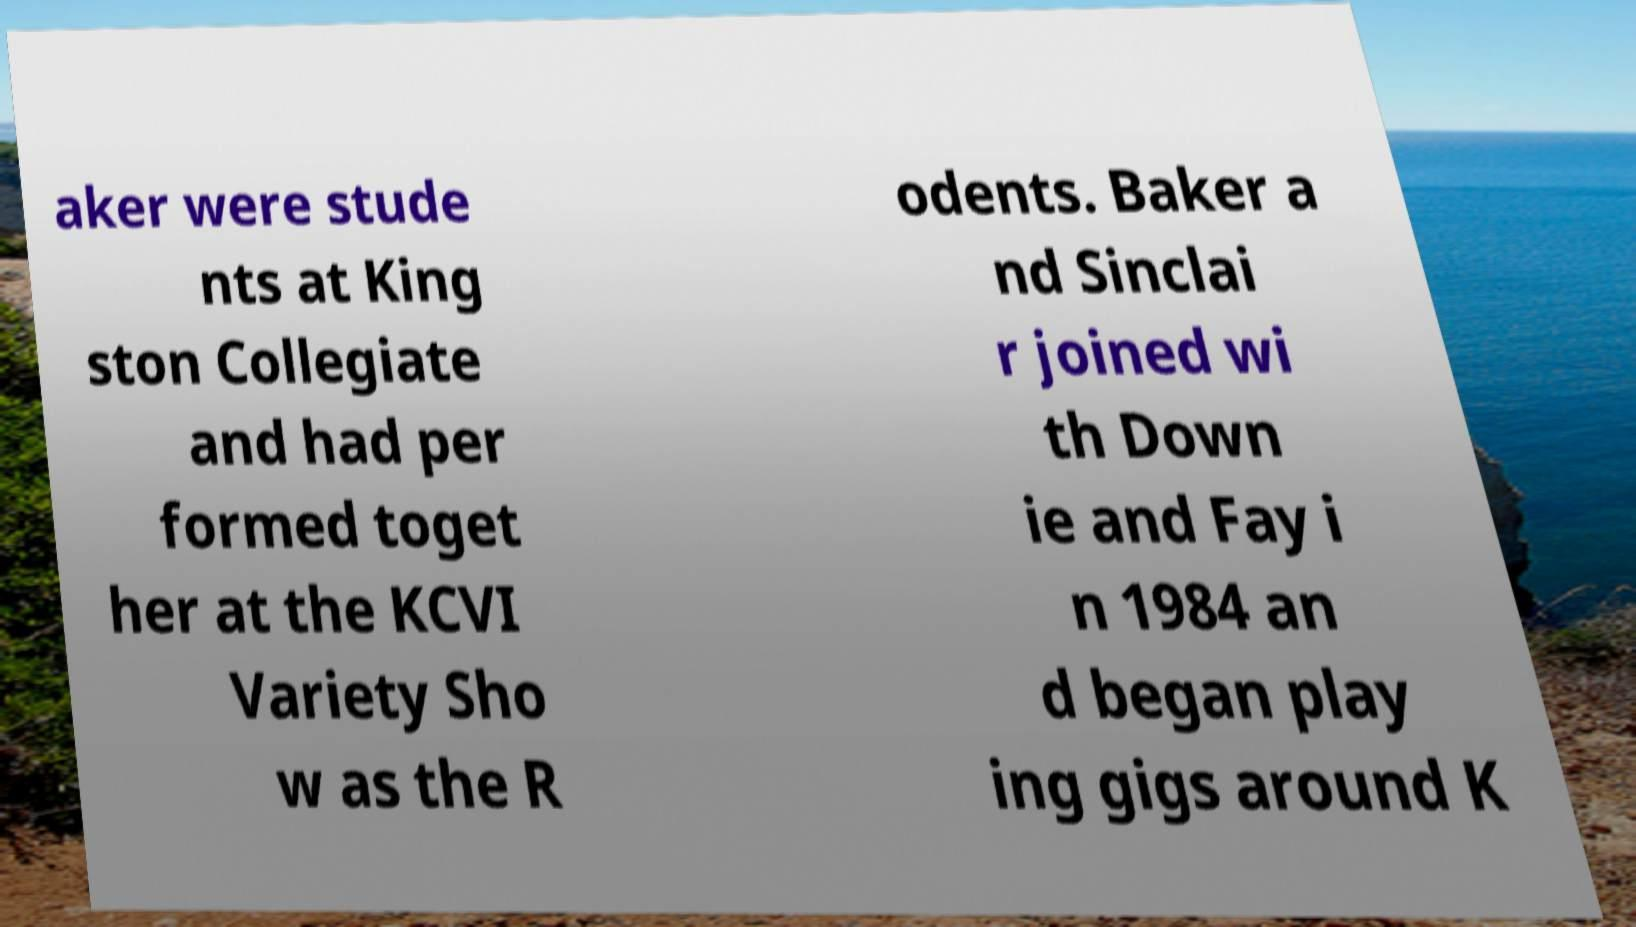Please read and relay the text visible in this image. What does it say? aker were stude nts at King ston Collegiate and had per formed toget her at the KCVI Variety Sho w as the R odents. Baker a nd Sinclai r joined wi th Down ie and Fay i n 1984 an d began play ing gigs around K 